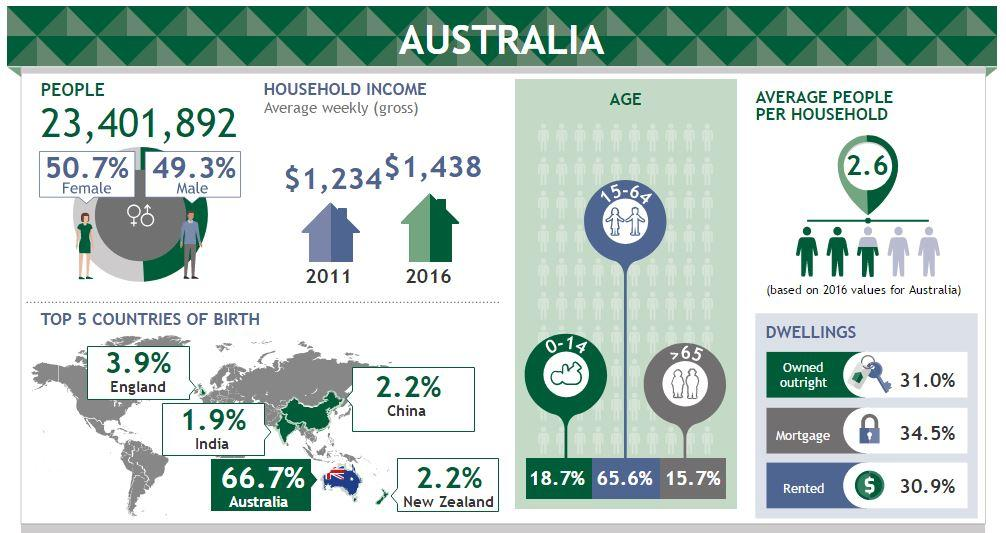Give some essential details in this illustration. According to the given data, approximately 15.7% of people are senior citizens. According to data, the age group that comprises the largest portion of the population in Australia is 15-64 years old. Mortgages are the most common type of dwelling. In Australia, the gender that is slightly more prevalent is female. Approximately 2.2% of the Chinese population resides in Australia. 